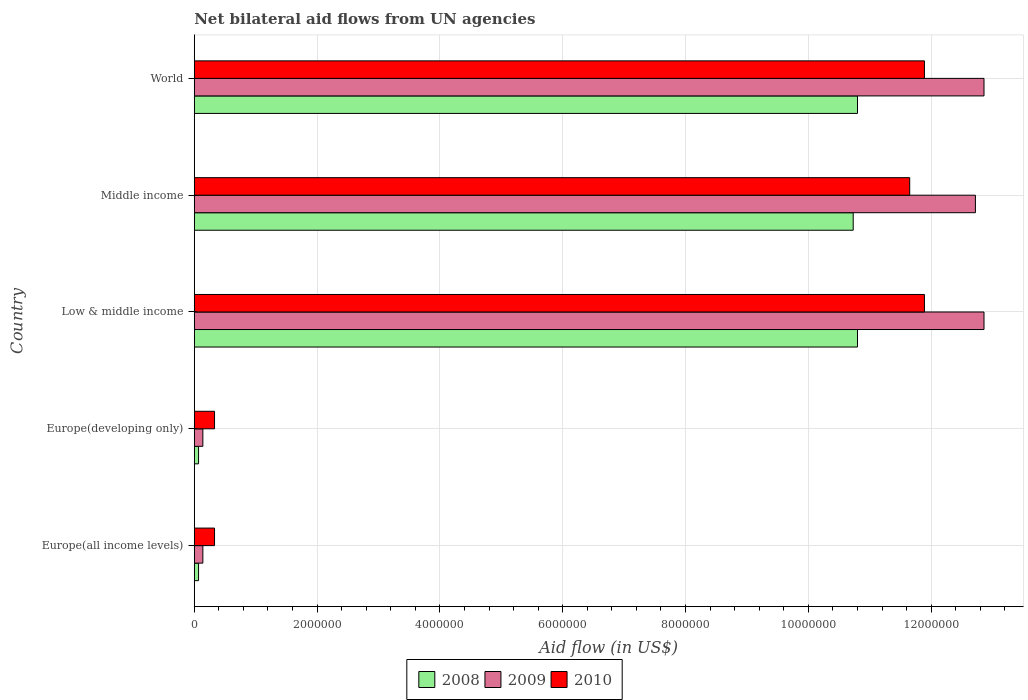Are the number of bars on each tick of the Y-axis equal?
Your answer should be compact. Yes. How many bars are there on the 5th tick from the top?
Offer a very short reply. 3. What is the label of the 1st group of bars from the top?
Offer a very short reply. World. In how many cases, is the number of bars for a given country not equal to the number of legend labels?
Keep it short and to the point. 0. What is the net bilateral aid flow in 2010 in World?
Ensure brevity in your answer.  1.19e+07. Across all countries, what is the maximum net bilateral aid flow in 2009?
Keep it short and to the point. 1.29e+07. Across all countries, what is the minimum net bilateral aid flow in 2008?
Your answer should be very brief. 7.00e+04. In which country was the net bilateral aid flow in 2009 minimum?
Offer a terse response. Europe(all income levels). What is the total net bilateral aid flow in 2008 in the graph?
Offer a very short reply. 3.25e+07. What is the difference between the net bilateral aid flow in 2008 in Europe(developing only) and the net bilateral aid flow in 2009 in World?
Ensure brevity in your answer.  -1.28e+07. What is the average net bilateral aid flow in 2008 per country?
Your response must be concise. 6.49e+06. What is the difference between the net bilateral aid flow in 2008 and net bilateral aid flow in 2010 in World?
Your answer should be very brief. -1.09e+06. In how many countries, is the net bilateral aid flow in 2008 greater than 4000000 US$?
Your answer should be very brief. 3. What is the ratio of the net bilateral aid flow in 2009 in Europe(all income levels) to that in World?
Your answer should be very brief. 0.01. Is the net bilateral aid flow in 2009 in Europe(developing only) less than that in World?
Offer a very short reply. Yes. What is the difference between the highest and the second highest net bilateral aid flow in 2008?
Ensure brevity in your answer.  0. What is the difference between the highest and the lowest net bilateral aid flow in 2009?
Make the answer very short. 1.27e+07. What does the 3rd bar from the top in Europe(all income levels) represents?
Ensure brevity in your answer.  2008. Is it the case that in every country, the sum of the net bilateral aid flow in 2009 and net bilateral aid flow in 2008 is greater than the net bilateral aid flow in 2010?
Provide a short and direct response. No. How many bars are there?
Your response must be concise. 15. Are all the bars in the graph horizontal?
Ensure brevity in your answer.  Yes. What is the difference between two consecutive major ticks on the X-axis?
Ensure brevity in your answer.  2.00e+06. Are the values on the major ticks of X-axis written in scientific E-notation?
Provide a succinct answer. No. Does the graph contain grids?
Make the answer very short. Yes. What is the title of the graph?
Make the answer very short. Net bilateral aid flows from UN agencies. What is the label or title of the X-axis?
Your answer should be compact. Aid flow (in US$). What is the label or title of the Y-axis?
Give a very brief answer. Country. What is the Aid flow (in US$) of 2010 in Europe(all income levels)?
Provide a short and direct response. 3.30e+05. What is the Aid flow (in US$) of 2009 in Europe(developing only)?
Your answer should be compact. 1.40e+05. What is the Aid flow (in US$) of 2008 in Low & middle income?
Provide a short and direct response. 1.08e+07. What is the Aid flow (in US$) of 2009 in Low & middle income?
Keep it short and to the point. 1.29e+07. What is the Aid flow (in US$) of 2010 in Low & middle income?
Keep it short and to the point. 1.19e+07. What is the Aid flow (in US$) of 2008 in Middle income?
Your response must be concise. 1.07e+07. What is the Aid flow (in US$) of 2009 in Middle income?
Make the answer very short. 1.27e+07. What is the Aid flow (in US$) in 2010 in Middle income?
Provide a succinct answer. 1.16e+07. What is the Aid flow (in US$) in 2008 in World?
Provide a succinct answer. 1.08e+07. What is the Aid flow (in US$) in 2009 in World?
Give a very brief answer. 1.29e+07. What is the Aid flow (in US$) in 2010 in World?
Keep it short and to the point. 1.19e+07. Across all countries, what is the maximum Aid flow (in US$) in 2008?
Provide a succinct answer. 1.08e+07. Across all countries, what is the maximum Aid flow (in US$) in 2009?
Give a very brief answer. 1.29e+07. Across all countries, what is the maximum Aid flow (in US$) in 2010?
Make the answer very short. 1.19e+07. Across all countries, what is the minimum Aid flow (in US$) of 2008?
Your answer should be very brief. 7.00e+04. Across all countries, what is the minimum Aid flow (in US$) of 2009?
Your response must be concise. 1.40e+05. Across all countries, what is the minimum Aid flow (in US$) in 2010?
Your answer should be compact. 3.30e+05. What is the total Aid flow (in US$) of 2008 in the graph?
Your answer should be very brief. 3.25e+07. What is the total Aid flow (in US$) of 2009 in the graph?
Ensure brevity in your answer.  3.87e+07. What is the total Aid flow (in US$) in 2010 in the graph?
Your response must be concise. 3.61e+07. What is the difference between the Aid flow (in US$) of 2008 in Europe(all income levels) and that in Europe(developing only)?
Your answer should be compact. 0. What is the difference between the Aid flow (in US$) of 2010 in Europe(all income levels) and that in Europe(developing only)?
Provide a succinct answer. 0. What is the difference between the Aid flow (in US$) in 2008 in Europe(all income levels) and that in Low & middle income?
Provide a succinct answer. -1.07e+07. What is the difference between the Aid flow (in US$) in 2009 in Europe(all income levels) and that in Low & middle income?
Give a very brief answer. -1.27e+07. What is the difference between the Aid flow (in US$) in 2010 in Europe(all income levels) and that in Low & middle income?
Offer a terse response. -1.16e+07. What is the difference between the Aid flow (in US$) in 2008 in Europe(all income levels) and that in Middle income?
Your answer should be very brief. -1.07e+07. What is the difference between the Aid flow (in US$) of 2009 in Europe(all income levels) and that in Middle income?
Your answer should be compact. -1.26e+07. What is the difference between the Aid flow (in US$) in 2010 in Europe(all income levels) and that in Middle income?
Your answer should be very brief. -1.13e+07. What is the difference between the Aid flow (in US$) of 2008 in Europe(all income levels) and that in World?
Offer a terse response. -1.07e+07. What is the difference between the Aid flow (in US$) of 2009 in Europe(all income levels) and that in World?
Offer a terse response. -1.27e+07. What is the difference between the Aid flow (in US$) of 2010 in Europe(all income levels) and that in World?
Your response must be concise. -1.16e+07. What is the difference between the Aid flow (in US$) in 2008 in Europe(developing only) and that in Low & middle income?
Your answer should be compact. -1.07e+07. What is the difference between the Aid flow (in US$) of 2009 in Europe(developing only) and that in Low & middle income?
Give a very brief answer. -1.27e+07. What is the difference between the Aid flow (in US$) in 2010 in Europe(developing only) and that in Low & middle income?
Your response must be concise. -1.16e+07. What is the difference between the Aid flow (in US$) of 2008 in Europe(developing only) and that in Middle income?
Offer a very short reply. -1.07e+07. What is the difference between the Aid flow (in US$) of 2009 in Europe(developing only) and that in Middle income?
Provide a short and direct response. -1.26e+07. What is the difference between the Aid flow (in US$) in 2010 in Europe(developing only) and that in Middle income?
Offer a very short reply. -1.13e+07. What is the difference between the Aid flow (in US$) of 2008 in Europe(developing only) and that in World?
Your answer should be very brief. -1.07e+07. What is the difference between the Aid flow (in US$) in 2009 in Europe(developing only) and that in World?
Make the answer very short. -1.27e+07. What is the difference between the Aid flow (in US$) of 2010 in Europe(developing only) and that in World?
Ensure brevity in your answer.  -1.16e+07. What is the difference between the Aid flow (in US$) of 2008 in Low & middle income and that in Middle income?
Your answer should be compact. 7.00e+04. What is the difference between the Aid flow (in US$) in 2009 in Low & middle income and that in Middle income?
Provide a short and direct response. 1.40e+05. What is the difference between the Aid flow (in US$) in 2008 in Low & middle income and that in World?
Offer a very short reply. 0. What is the difference between the Aid flow (in US$) of 2009 in Low & middle income and that in World?
Keep it short and to the point. 0. What is the difference between the Aid flow (in US$) of 2008 in Europe(all income levels) and the Aid flow (in US$) of 2010 in Europe(developing only)?
Your response must be concise. -2.60e+05. What is the difference between the Aid flow (in US$) of 2008 in Europe(all income levels) and the Aid flow (in US$) of 2009 in Low & middle income?
Give a very brief answer. -1.28e+07. What is the difference between the Aid flow (in US$) of 2008 in Europe(all income levels) and the Aid flow (in US$) of 2010 in Low & middle income?
Make the answer very short. -1.18e+07. What is the difference between the Aid flow (in US$) of 2009 in Europe(all income levels) and the Aid flow (in US$) of 2010 in Low & middle income?
Your answer should be very brief. -1.18e+07. What is the difference between the Aid flow (in US$) in 2008 in Europe(all income levels) and the Aid flow (in US$) in 2009 in Middle income?
Offer a very short reply. -1.26e+07. What is the difference between the Aid flow (in US$) of 2008 in Europe(all income levels) and the Aid flow (in US$) of 2010 in Middle income?
Give a very brief answer. -1.16e+07. What is the difference between the Aid flow (in US$) in 2009 in Europe(all income levels) and the Aid flow (in US$) in 2010 in Middle income?
Provide a succinct answer. -1.15e+07. What is the difference between the Aid flow (in US$) in 2008 in Europe(all income levels) and the Aid flow (in US$) in 2009 in World?
Provide a short and direct response. -1.28e+07. What is the difference between the Aid flow (in US$) in 2008 in Europe(all income levels) and the Aid flow (in US$) in 2010 in World?
Offer a terse response. -1.18e+07. What is the difference between the Aid flow (in US$) in 2009 in Europe(all income levels) and the Aid flow (in US$) in 2010 in World?
Your response must be concise. -1.18e+07. What is the difference between the Aid flow (in US$) in 2008 in Europe(developing only) and the Aid flow (in US$) in 2009 in Low & middle income?
Ensure brevity in your answer.  -1.28e+07. What is the difference between the Aid flow (in US$) in 2008 in Europe(developing only) and the Aid flow (in US$) in 2010 in Low & middle income?
Your answer should be very brief. -1.18e+07. What is the difference between the Aid flow (in US$) in 2009 in Europe(developing only) and the Aid flow (in US$) in 2010 in Low & middle income?
Your answer should be very brief. -1.18e+07. What is the difference between the Aid flow (in US$) in 2008 in Europe(developing only) and the Aid flow (in US$) in 2009 in Middle income?
Ensure brevity in your answer.  -1.26e+07. What is the difference between the Aid flow (in US$) in 2008 in Europe(developing only) and the Aid flow (in US$) in 2010 in Middle income?
Your answer should be compact. -1.16e+07. What is the difference between the Aid flow (in US$) of 2009 in Europe(developing only) and the Aid flow (in US$) of 2010 in Middle income?
Your answer should be very brief. -1.15e+07. What is the difference between the Aid flow (in US$) in 2008 in Europe(developing only) and the Aid flow (in US$) in 2009 in World?
Your answer should be compact. -1.28e+07. What is the difference between the Aid flow (in US$) in 2008 in Europe(developing only) and the Aid flow (in US$) in 2010 in World?
Offer a terse response. -1.18e+07. What is the difference between the Aid flow (in US$) of 2009 in Europe(developing only) and the Aid flow (in US$) of 2010 in World?
Your response must be concise. -1.18e+07. What is the difference between the Aid flow (in US$) in 2008 in Low & middle income and the Aid flow (in US$) in 2009 in Middle income?
Give a very brief answer. -1.92e+06. What is the difference between the Aid flow (in US$) of 2008 in Low & middle income and the Aid flow (in US$) of 2010 in Middle income?
Offer a terse response. -8.50e+05. What is the difference between the Aid flow (in US$) of 2009 in Low & middle income and the Aid flow (in US$) of 2010 in Middle income?
Give a very brief answer. 1.21e+06. What is the difference between the Aid flow (in US$) in 2008 in Low & middle income and the Aid flow (in US$) in 2009 in World?
Offer a terse response. -2.06e+06. What is the difference between the Aid flow (in US$) in 2008 in Low & middle income and the Aid flow (in US$) in 2010 in World?
Ensure brevity in your answer.  -1.09e+06. What is the difference between the Aid flow (in US$) in 2009 in Low & middle income and the Aid flow (in US$) in 2010 in World?
Make the answer very short. 9.70e+05. What is the difference between the Aid flow (in US$) in 2008 in Middle income and the Aid flow (in US$) in 2009 in World?
Your answer should be compact. -2.13e+06. What is the difference between the Aid flow (in US$) in 2008 in Middle income and the Aid flow (in US$) in 2010 in World?
Make the answer very short. -1.16e+06. What is the difference between the Aid flow (in US$) of 2009 in Middle income and the Aid flow (in US$) of 2010 in World?
Keep it short and to the point. 8.30e+05. What is the average Aid flow (in US$) of 2008 per country?
Your answer should be very brief. 6.49e+06. What is the average Aid flow (in US$) of 2009 per country?
Your answer should be very brief. 7.74e+06. What is the average Aid flow (in US$) in 2010 per country?
Offer a terse response. 7.22e+06. What is the difference between the Aid flow (in US$) of 2008 and Aid flow (in US$) of 2009 in Europe(all income levels)?
Give a very brief answer. -7.00e+04. What is the difference between the Aid flow (in US$) of 2008 and Aid flow (in US$) of 2009 in Europe(developing only)?
Your answer should be very brief. -7.00e+04. What is the difference between the Aid flow (in US$) of 2008 and Aid flow (in US$) of 2010 in Europe(developing only)?
Your answer should be compact. -2.60e+05. What is the difference between the Aid flow (in US$) in 2008 and Aid flow (in US$) in 2009 in Low & middle income?
Provide a succinct answer. -2.06e+06. What is the difference between the Aid flow (in US$) of 2008 and Aid flow (in US$) of 2010 in Low & middle income?
Give a very brief answer. -1.09e+06. What is the difference between the Aid flow (in US$) of 2009 and Aid flow (in US$) of 2010 in Low & middle income?
Your answer should be compact. 9.70e+05. What is the difference between the Aid flow (in US$) in 2008 and Aid flow (in US$) in 2009 in Middle income?
Your response must be concise. -1.99e+06. What is the difference between the Aid flow (in US$) in 2008 and Aid flow (in US$) in 2010 in Middle income?
Make the answer very short. -9.20e+05. What is the difference between the Aid flow (in US$) in 2009 and Aid flow (in US$) in 2010 in Middle income?
Ensure brevity in your answer.  1.07e+06. What is the difference between the Aid flow (in US$) of 2008 and Aid flow (in US$) of 2009 in World?
Provide a succinct answer. -2.06e+06. What is the difference between the Aid flow (in US$) of 2008 and Aid flow (in US$) of 2010 in World?
Keep it short and to the point. -1.09e+06. What is the difference between the Aid flow (in US$) in 2009 and Aid flow (in US$) in 2010 in World?
Make the answer very short. 9.70e+05. What is the ratio of the Aid flow (in US$) of 2008 in Europe(all income levels) to that in Europe(developing only)?
Provide a short and direct response. 1. What is the ratio of the Aid flow (in US$) of 2009 in Europe(all income levels) to that in Europe(developing only)?
Provide a short and direct response. 1. What is the ratio of the Aid flow (in US$) in 2010 in Europe(all income levels) to that in Europe(developing only)?
Your response must be concise. 1. What is the ratio of the Aid flow (in US$) of 2008 in Europe(all income levels) to that in Low & middle income?
Offer a terse response. 0.01. What is the ratio of the Aid flow (in US$) in 2009 in Europe(all income levels) to that in Low & middle income?
Make the answer very short. 0.01. What is the ratio of the Aid flow (in US$) of 2010 in Europe(all income levels) to that in Low & middle income?
Keep it short and to the point. 0.03. What is the ratio of the Aid flow (in US$) in 2008 in Europe(all income levels) to that in Middle income?
Provide a short and direct response. 0.01. What is the ratio of the Aid flow (in US$) in 2009 in Europe(all income levels) to that in Middle income?
Give a very brief answer. 0.01. What is the ratio of the Aid flow (in US$) of 2010 in Europe(all income levels) to that in Middle income?
Keep it short and to the point. 0.03. What is the ratio of the Aid flow (in US$) in 2008 in Europe(all income levels) to that in World?
Your answer should be very brief. 0.01. What is the ratio of the Aid flow (in US$) in 2009 in Europe(all income levels) to that in World?
Offer a very short reply. 0.01. What is the ratio of the Aid flow (in US$) of 2010 in Europe(all income levels) to that in World?
Your answer should be very brief. 0.03. What is the ratio of the Aid flow (in US$) in 2008 in Europe(developing only) to that in Low & middle income?
Provide a succinct answer. 0.01. What is the ratio of the Aid flow (in US$) in 2009 in Europe(developing only) to that in Low & middle income?
Your answer should be very brief. 0.01. What is the ratio of the Aid flow (in US$) of 2010 in Europe(developing only) to that in Low & middle income?
Give a very brief answer. 0.03. What is the ratio of the Aid flow (in US$) in 2008 in Europe(developing only) to that in Middle income?
Provide a succinct answer. 0.01. What is the ratio of the Aid flow (in US$) in 2009 in Europe(developing only) to that in Middle income?
Your answer should be compact. 0.01. What is the ratio of the Aid flow (in US$) in 2010 in Europe(developing only) to that in Middle income?
Ensure brevity in your answer.  0.03. What is the ratio of the Aid flow (in US$) of 2008 in Europe(developing only) to that in World?
Offer a terse response. 0.01. What is the ratio of the Aid flow (in US$) of 2009 in Europe(developing only) to that in World?
Make the answer very short. 0.01. What is the ratio of the Aid flow (in US$) of 2010 in Europe(developing only) to that in World?
Provide a succinct answer. 0.03. What is the ratio of the Aid flow (in US$) of 2008 in Low & middle income to that in Middle income?
Keep it short and to the point. 1.01. What is the ratio of the Aid flow (in US$) of 2009 in Low & middle income to that in Middle income?
Your response must be concise. 1.01. What is the ratio of the Aid flow (in US$) of 2010 in Low & middle income to that in Middle income?
Give a very brief answer. 1.02. What is the ratio of the Aid flow (in US$) of 2009 in Low & middle income to that in World?
Your response must be concise. 1. What is the ratio of the Aid flow (in US$) of 2010 in Low & middle income to that in World?
Your answer should be very brief. 1. What is the ratio of the Aid flow (in US$) of 2009 in Middle income to that in World?
Keep it short and to the point. 0.99. What is the ratio of the Aid flow (in US$) of 2010 in Middle income to that in World?
Offer a very short reply. 0.98. What is the difference between the highest and the second highest Aid flow (in US$) in 2008?
Your answer should be compact. 0. What is the difference between the highest and the second highest Aid flow (in US$) in 2010?
Ensure brevity in your answer.  0. What is the difference between the highest and the lowest Aid flow (in US$) in 2008?
Your answer should be very brief. 1.07e+07. What is the difference between the highest and the lowest Aid flow (in US$) of 2009?
Your answer should be very brief. 1.27e+07. What is the difference between the highest and the lowest Aid flow (in US$) of 2010?
Make the answer very short. 1.16e+07. 